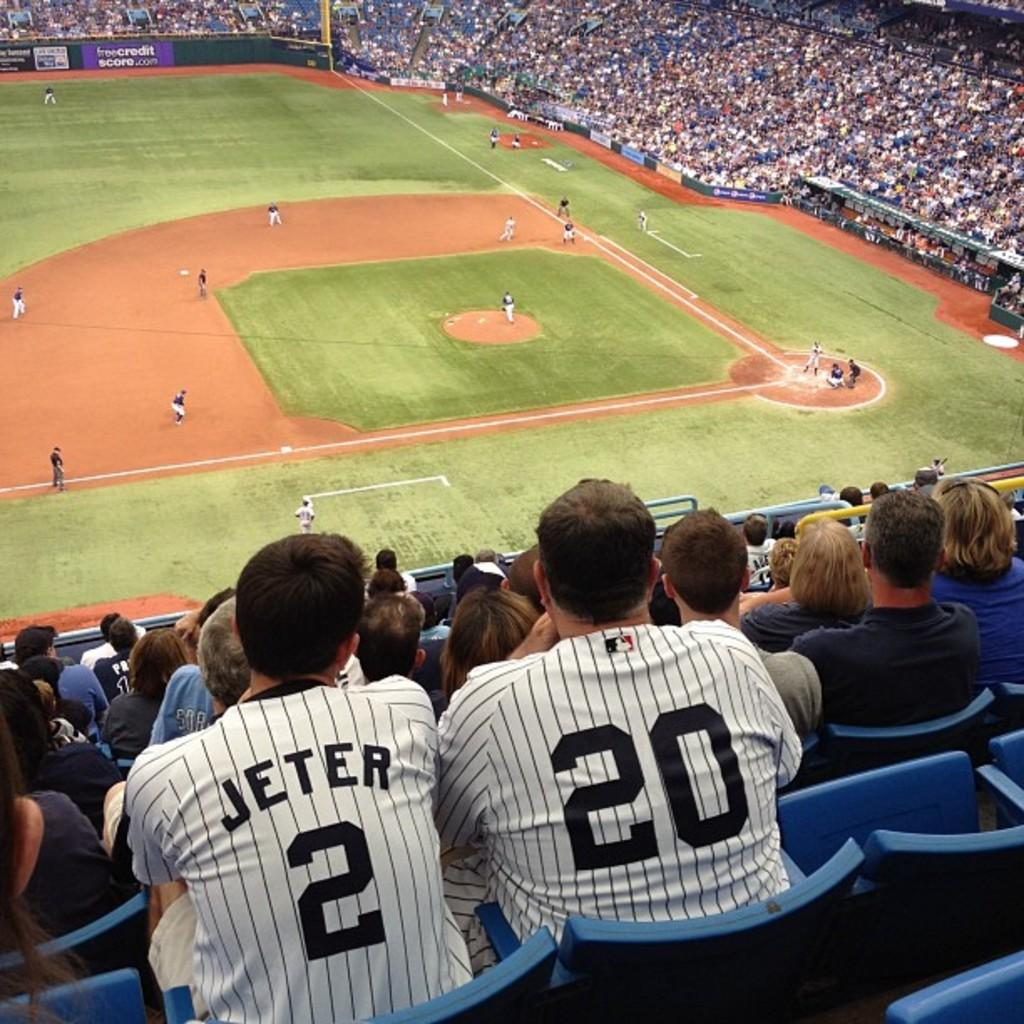Provide a one-sentence caption for the provided image. The man watched the baseball game as he wore his Jeter jersey. 